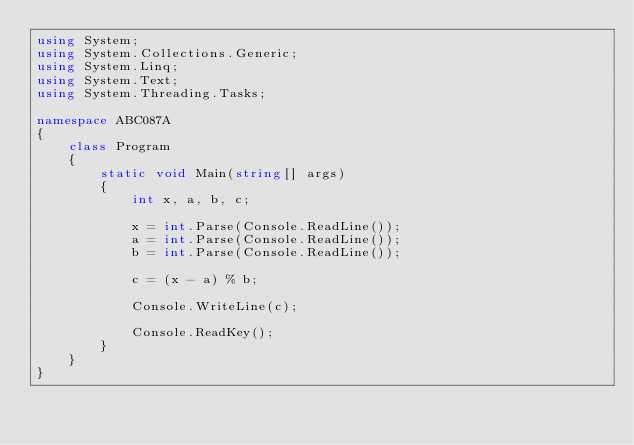<code> <loc_0><loc_0><loc_500><loc_500><_C#_>using System;
using System.Collections.Generic;
using System.Linq;
using System.Text;
using System.Threading.Tasks;

namespace ABC087A
{
    class Program
    {
        static void Main(string[] args)
        {
            int x, a, b, c;

            x = int.Parse(Console.ReadLine());
            a = int.Parse(Console.ReadLine());
            b = int.Parse(Console.ReadLine());

            c = (x - a) % b;

            Console.WriteLine(c);

            Console.ReadKey();
        }
    }
}</code> 